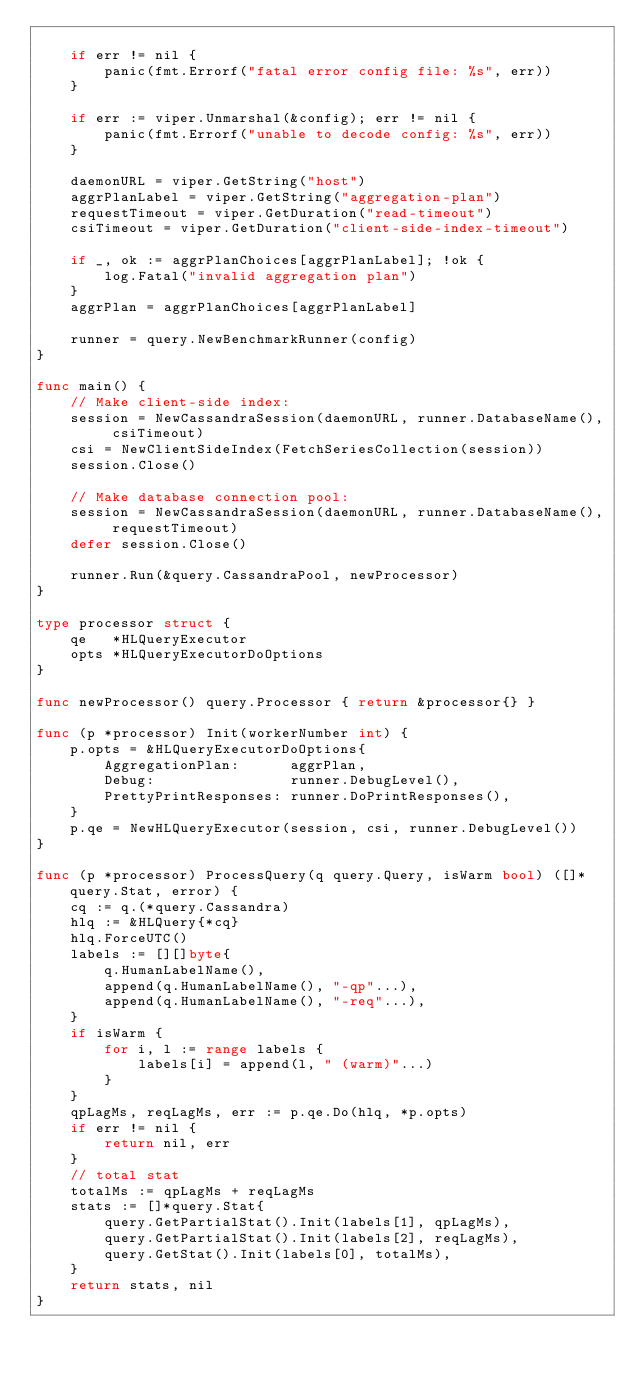<code> <loc_0><loc_0><loc_500><loc_500><_Go_>
	if err != nil {
		panic(fmt.Errorf("fatal error config file: %s", err))
	}

	if err := viper.Unmarshal(&config); err != nil {
		panic(fmt.Errorf("unable to decode config: %s", err))
	}

	daemonURL = viper.GetString("host")
	aggrPlanLabel = viper.GetString("aggregation-plan")
	requestTimeout = viper.GetDuration("read-timeout")
	csiTimeout = viper.GetDuration("client-side-index-timeout")

	if _, ok := aggrPlanChoices[aggrPlanLabel]; !ok {
		log.Fatal("invalid aggregation plan")
	}
	aggrPlan = aggrPlanChoices[aggrPlanLabel]

	runner = query.NewBenchmarkRunner(config)
}

func main() {
	// Make client-side index:
	session = NewCassandraSession(daemonURL, runner.DatabaseName(), csiTimeout)
	csi = NewClientSideIndex(FetchSeriesCollection(session))
	session.Close()

	// Make database connection pool:
	session = NewCassandraSession(daemonURL, runner.DatabaseName(), requestTimeout)
	defer session.Close()

	runner.Run(&query.CassandraPool, newProcessor)
}

type processor struct {
	qe   *HLQueryExecutor
	opts *HLQueryExecutorDoOptions
}

func newProcessor() query.Processor { return &processor{} }

func (p *processor) Init(workerNumber int) {
	p.opts = &HLQueryExecutorDoOptions{
		AggregationPlan:      aggrPlan,
		Debug:                runner.DebugLevel(),
		PrettyPrintResponses: runner.DoPrintResponses(),
	}
	p.qe = NewHLQueryExecutor(session, csi, runner.DebugLevel())
}

func (p *processor) ProcessQuery(q query.Query, isWarm bool) ([]*query.Stat, error) {
	cq := q.(*query.Cassandra)
	hlq := &HLQuery{*cq}
	hlq.ForceUTC()
	labels := [][]byte{
		q.HumanLabelName(),
		append(q.HumanLabelName(), "-qp"...),
		append(q.HumanLabelName(), "-req"...),
	}
	if isWarm {
		for i, l := range labels {
			labels[i] = append(l, " (warm)"...)
		}
	}
	qpLagMs, reqLagMs, err := p.qe.Do(hlq, *p.opts)
	if err != nil {
		return nil, err
	}
	// total stat
	totalMs := qpLagMs + reqLagMs
	stats := []*query.Stat{
		query.GetPartialStat().Init(labels[1], qpLagMs),
		query.GetPartialStat().Init(labels[2], reqLagMs),
		query.GetStat().Init(labels[0], totalMs),
	}
	return stats, nil
}
</code> 